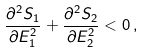Convert formula to latex. <formula><loc_0><loc_0><loc_500><loc_500>\frac { \partial ^ { 2 } S _ { 1 } } { \partial E _ { 1 } ^ { 2 } } + \frac { \partial ^ { 2 } S _ { 2 } } { \partial E _ { 2 } ^ { 2 } } < 0 \, ,</formula> 